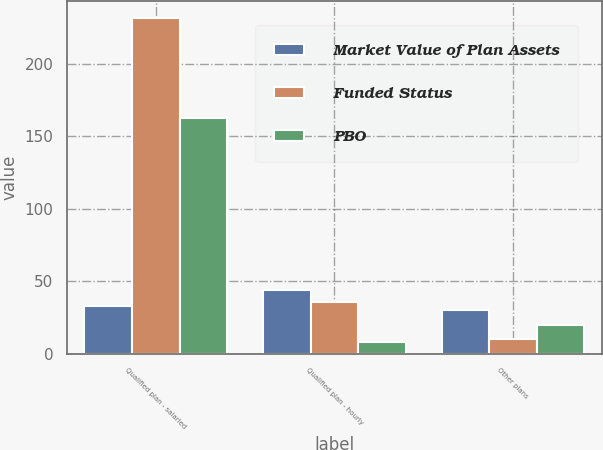Convert chart. <chart><loc_0><loc_0><loc_500><loc_500><stacked_bar_chart><ecel><fcel>Qualified plan - salaried<fcel>Qualified plan - hourly<fcel>Other plans<nl><fcel>Market Value of Plan Assets<fcel>33<fcel>44<fcel>30<nl><fcel>Funded Status<fcel>232<fcel>36<fcel>10<nl><fcel>PBO<fcel>163<fcel>8<fcel>20<nl></chart> 